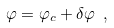<formula> <loc_0><loc_0><loc_500><loc_500>\varphi = \varphi _ { c } + \delta \varphi \ ,</formula> 